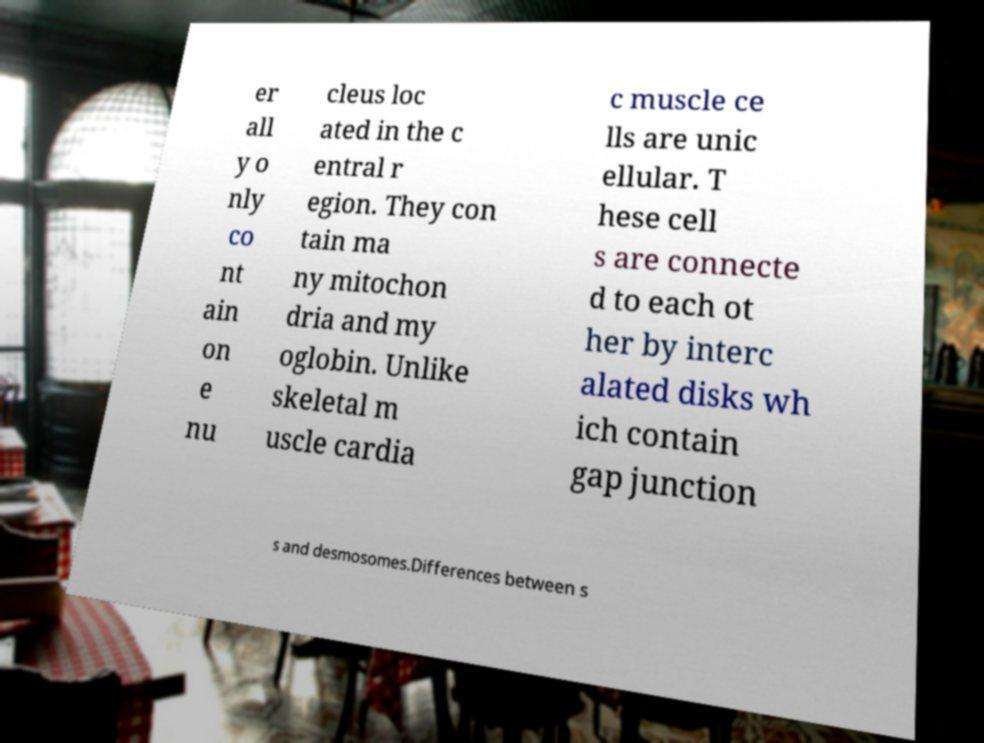Please read and relay the text visible in this image. What does it say? er all y o nly co nt ain on e nu cleus loc ated in the c entral r egion. They con tain ma ny mitochon dria and my oglobin. Unlike skeletal m uscle cardia c muscle ce lls are unic ellular. T hese cell s are connecte d to each ot her by interc alated disks wh ich contain gap junction s and desmosomes.Differences between s 